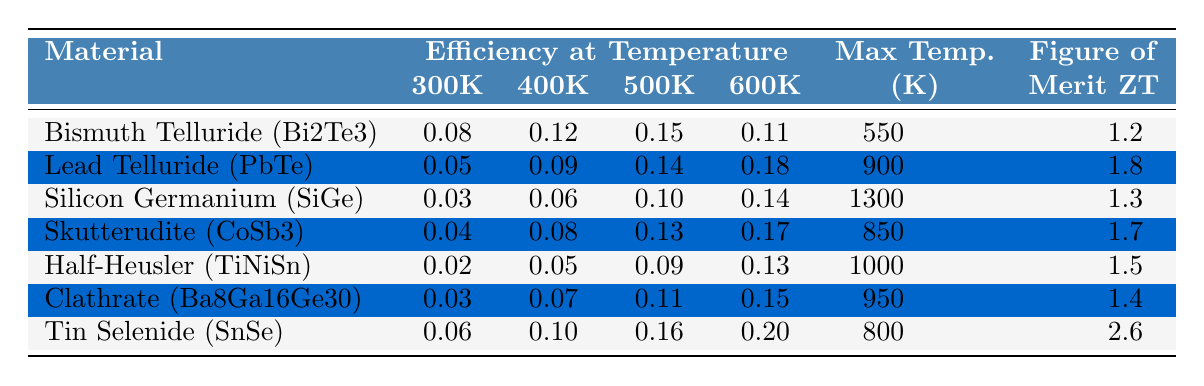What is the efficiency of Bismuth Telluride at 400K? The table indicates the efficiency of Bismuth Telluride (Bi2Te3) at 400K is listed as 0.12.
Answer: 0.12 Which material has the highest efficiency at 600K? According to the table, Tin Selenide (SnSe) has the highest efficiency at 600K, which is 0.20.
Answer: Tin Selenide (SnSe) What is the difference in efficiency at 500K between Lead Telluride and Skutterudite? The efficiency of Lead Telluride at 500K is 0.14, while for Skutterudite it is 0.13. The difference is 0.14 - 0.13 = 0.01.
Answer: 0.01 Is the maximum temperature for Silicon Germanium higher than that for Clathrate? The maximum temperature for Silicon Germanium (1300K) is indeed higher than that for Clathrate (950K).
Answer: Yes What is the average efficiency of Half-Heusler across all temperature points? The efficiencies at 300K, 400K, 500K, and 600K for Half-Heusler are 0.02, 0.05, 0.09, and 0.13 respectively. The sum is 0.02 + 0.05 + 0.09 + 0.13 = 0.29, and there are 4 temperature points. Therefore, the average efficiency is 0.29 / 4 = 0.0725.
Answer: 0.0725 Which material shows a consistent increase in efficiency across all temperature ranges? Reviewing the table, Lead Telluride has increasing efficiencies from 300K (0.05) to 600K (0.18), showing a consistent upward trend across the temperature range.
Answer: Lead Telluride What is the figure of merit ZT for Tin Selenide? The table lists the figure of merit ZT for Tin Selenide (SnSe) as 2.6.
Answer: 2.6 Which material has the second-highest efficiency at 500K? At 500K, Bismuth Telluride shows an efficiency of 0.15 (highest), and Lead Telluride shows 0.14 (second highest). Thus, the second highest at 500K is Lead Telluride.
Answer: Lead Telluride How does the efficiency of Clathrate at 600K compare to that of Skutterudite at the same temperature? The efficiency of Clathrate at 600K is 0.15, while Skutterudite at 600K has an efficiency of 0.17. Since 0.15 is less than 0.17, Clathrate's efficiency is lower.
Answer: Clathrate's efficiency is lower If we want to consider materials with a figure of merit ZT greater than 1.5, which materials qualify? The materials with ZT greater than 1.5 are Lead Telluride (1.8), Skutterudite (1.7), Half-Heusler (1.5, which is not greater), and Tin Selenide (2.6). Thus, qualifying materials are Lead Telluride, Skutterudite, and Tin Selenide.
Answer: Lead Telluride, Skutterudite, Tin Selenide 